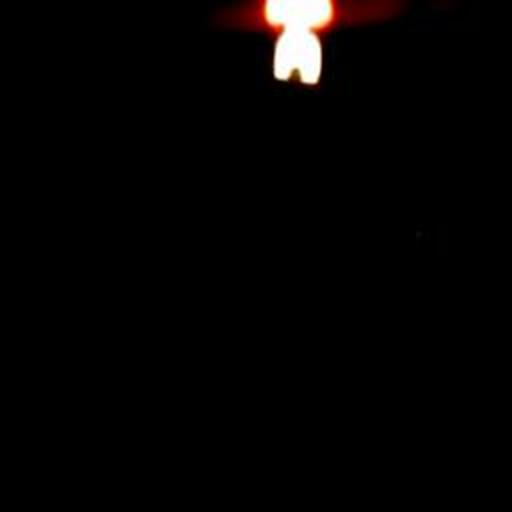Could the light in the image be symbolic of something? Yes, the solitary light could symbolize hope, guidance, or the presence of life amidst overwhelming darkness, often used to represent comfort in the face of adversity or a beacon leading towards a path of discovery. 